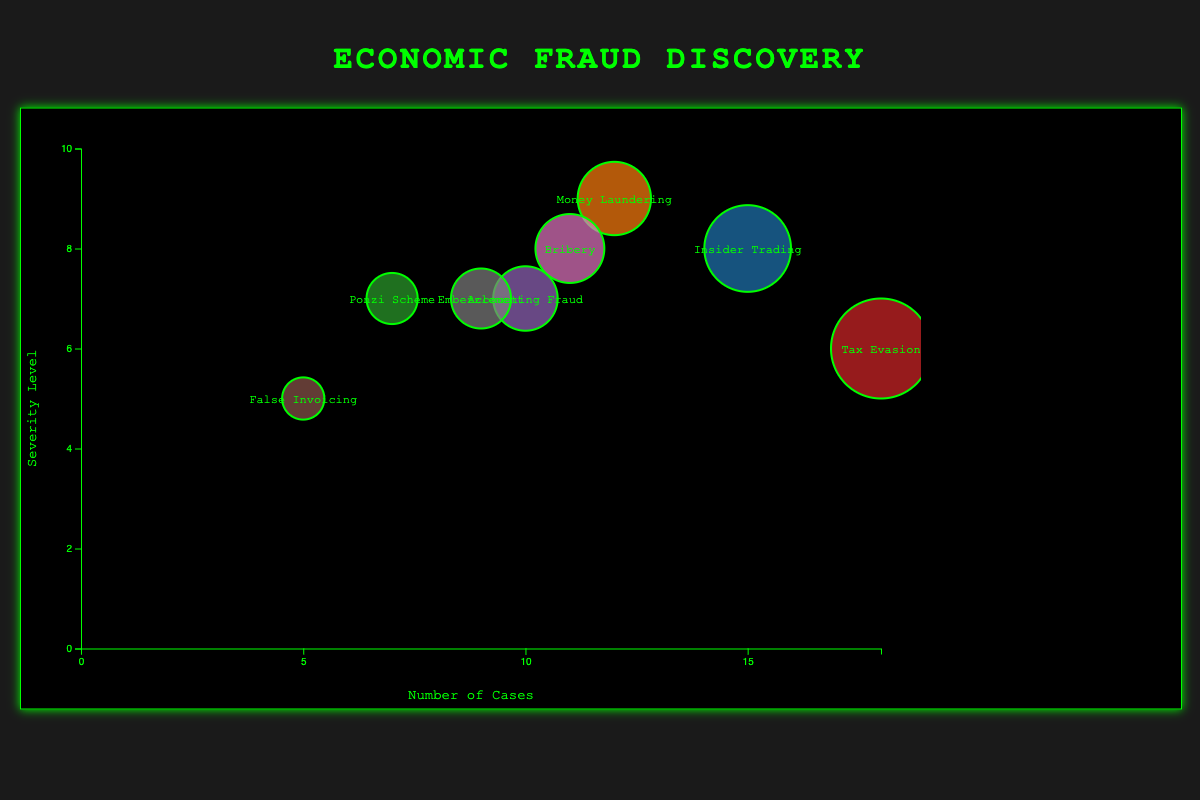What does the title of the figure indicate about the data being visualized? The title "Economic Fraud Discovery" indicates that the figure visualizes data about different types of economic fraud discovered and their respective characteristics.
Answer: Economic Fraud Discovery How many geographical locations are represented in the chart? Looking at the figure, there are eight bubbles representing data points for eight different geographical locations.
Answer: Eight Which type of economic fraud has the highest number of cases? By examining the x-axis where the number of cases is plotted, the bubble for "Tax Evasion" in Berlin, Germany has the highest x-coordinate value, indicating the highest number of cases.
Answer: Tax Evasion Which country has the lowest severity level of economic fraud? Referring to the y-axis where the severity level is plotted, the bubble for "False Invoicing" in Moscow, Russia has the lowest y-coordinate value, indicating the lowest severity level.
Answer: Russia Which two types of fraud have exactly seven severity levels? The y-coordinates of the bubbles show that "Ponzi Scheme" in Tokyo, Japan and "Accounting Fraud" in Sydney, Australia both align with a severity level of 7.
Answer: Ponzi Scheme and Accounting Fraud Compare the number of cases of Insider Trading and Bribery. Which one is higher? The x-coordinate for "Insider Trading" is 15, while for "Bribery" it is 11, comparing these values indicates that Insider Trading has a higher number of cases.
Answer: Insider Trading What is the total number of economic fraud cases discovered in Tokyo, Japan and Sydney, Australia? Combining the number of cases: 7 for Tokyo and 10 for Sydney results in a total of 7 + 10 = 17 cases.
Answer: 17 What is the difference in severity levels between Money Laundering and False Invoicing? The y-coordinate for "Money Laundering" is 9 and for "False Invoicing" it is 5. The difference is 9 - 5 = 4.
Answer: 4 Which fraud type has the largest bubble, indicating the most cases? Observing the sizes of the bubbles, the largest one corresponds to "Tax Evasion" in Berlin, Germany, suggesting it has the most cases.
Answer: Tax Evasion Compare the severity levels of Bribery in São Paulo, Brazil and Embezzlement in Toronto, Canada. The bubbles' y-coordinates show that Bribery has a severity level of 8 and Embezzlement has a severity level of 7; hence, Bribery has a higher severity level.
Answer: Bribery 